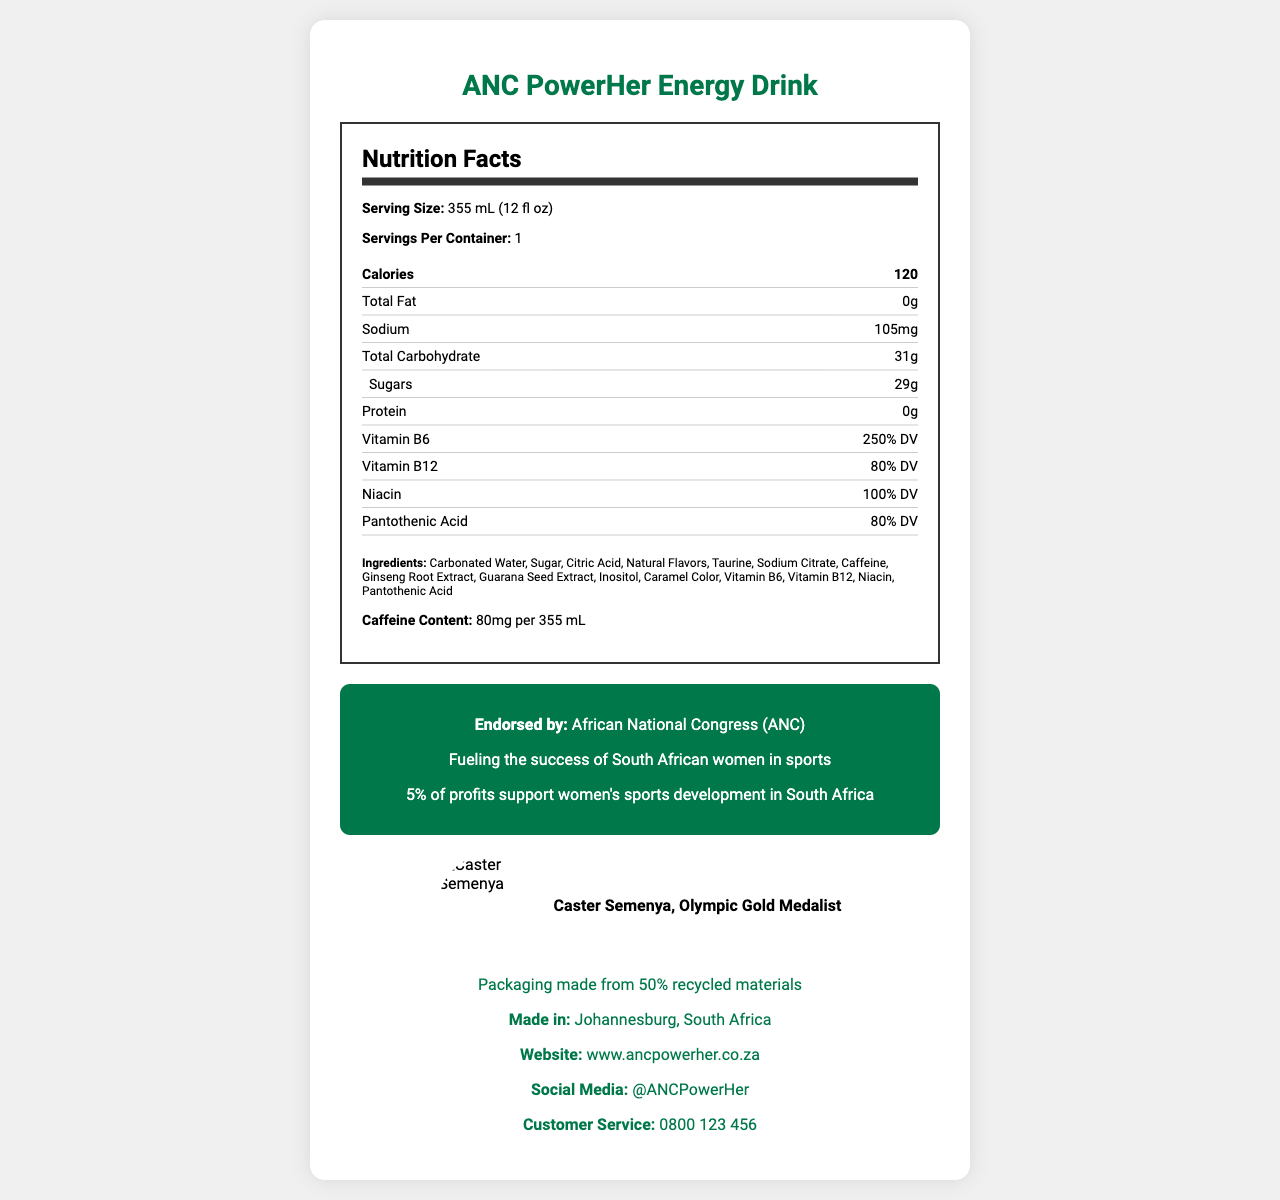what is the serving size of ANC PowerHer Energy Drink? The serving size is clearly indicated at the beginning of the Nutrition Facts section as "355 mL (12 fl oz)".
Answer: 355 mL (12 fl oz) how many servings per container are there? The document states that there is "1" serving per container right next to the serving size information.
Answer: 1 who is the featured athlete for this energy drink? The featured athlete is mentioned alongside her image and title, "Caster Semenya, Olympic Gold Medalist".
Answer: Caster Semenya, Olympic Gold Medalist what percentage of the Daily Value of Vitamin B6 does one serving contain? The percentage Daily Value for Vitamin B6 is listed as "250% DV" in the Nutrition Facts section.
Answer: 250% DV what is the total carbohydrate content in one serving? The total carbohydrate content for a serving is listed in the Nutrition Facts as "31g".
Answer: 31g how much caffeine does the ANC PowerHer Energy Drink contain? The caffeine content is specified in the Nutrition Facts section as "80mg per 355 mL".
Answer: 80mg per 355 mL what percentage of the profits supports women's sports development in South Africa? The document states that "5% of profits support women's sports development in South Africa".
Answer: 5% Multiple-choice: which of the following nutrients is not present in ANC PowerHer Energy Drink? A. Protein B. Vitamin B12 C. Sodium D. Total Fat The Nutrition Facts label indicates "0g" for Protein, confirming its absence.
Answer: A. Protein Multiple-choice: What is the sustainability note in the document? I. 100% recyclable packaging II. Made with 50% recycled materials III. Plant-based packaging IV. Biodegradable packaging The document notes that the packaging is "made from 50% recycled materials".
Answer: II. Made with 50% recycled materials is the ANC PowerHer Energy Drink endorsed by any organization? The document clearly states that it is endorsed by the African National Congress (ANC).
Answer: Yes describe the main idea of the document The document presents all critical information concerning the ANC PowerHer Energy Drink, from serving size and nutritional content to endorsements and social commitments, providing a comprehensive view of the product.
Answer: The document is a Nutrition Facts Label for the ANC PowerHer Energy Drink, endorsed by the African National Congress and featuring Olympic Gold Medalist Caster Semenya. It includes detailed nutritional information, ingredients, and highlights of the product's sustainability and women empowerment message. what is the exact amount of sodium in one serving? The amount of sodium per serving is listed as "105mg" in the Nutrition Facts section.
Answer: 105mg where is the ANC PowerHer Energy Drink manufactured? The manufacturing location is stated in the social info section as "Johannesburg, South Africa".
Answer: Johannesburg, South Africa list all the vitamins mentioned in the nutrition facts The vitamins listed in the Nutrition Facts are Vitamin B6, Vitamin B12, Niacin, and Pantothenic Acid.
Answer: Vitamin B6, Vitamin B12, Niacin, Pantothenic Acid why is African National Congress (ANC) mentioned in the document? The ANC's endorsement is explicitly mentioned in the document and highlighted in the branding and empowerment message.
Answer: The African National Congress (ANC) endorses the product. what flavors are included in the ANC PowerHer Energy Drink? The document lists "Natural Flavors" as an ingredient but does not specify the exact flavors.
Answer: Cannot be determined 